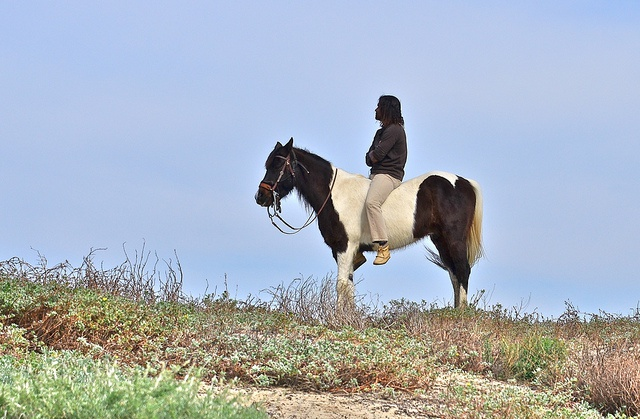Describe the objects in this image and their specific colors. I can see horse in lightblue, black, beige, tan, and gray tones and people in lightblue, black, and tan tones in this image. 